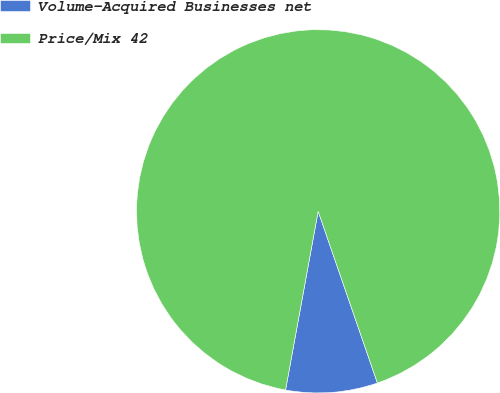Convert chart. <chart><loc_0><loc_0><loc_500><loc_500><pie_chart><fcel>Volume-Acquired Businesses net<fcel>Price/Mix 42<nl><fcel>8.16%<fcel>91.84%<nl></chart> 